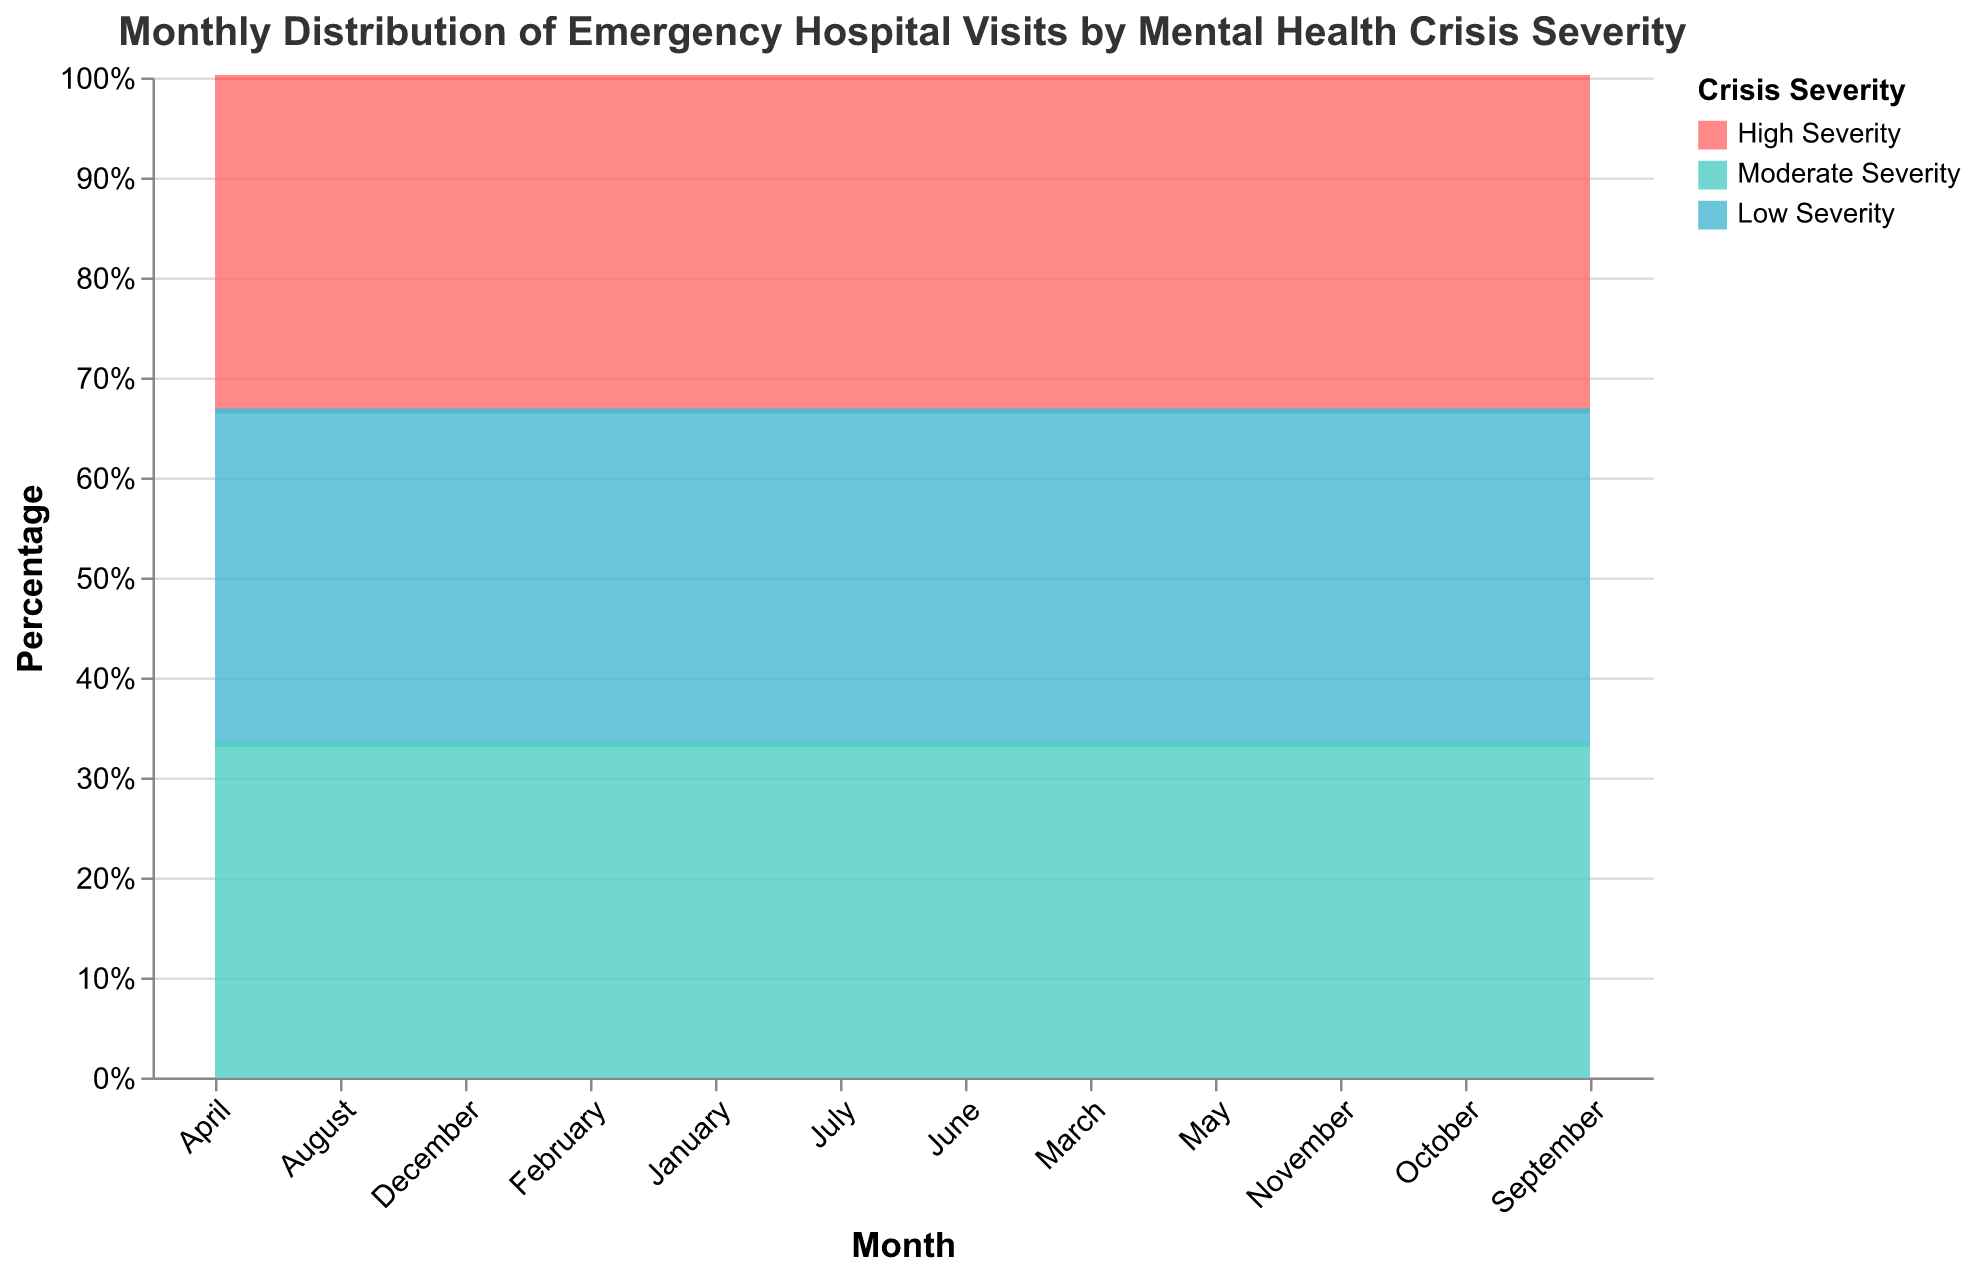What is the title of the chart? The title can be found at the top of the chart. It reads, "Monthly Distribution of Emergency Hospital Visits by Mental Health Crisis Severity."
Answer: Monthly Distribution of Emergency Hospital Visits by Mental Health Crisis Severity Which month has the highest percentage of high severity visits? By visually inspecting the chart, we can see that April and October have the highest normalized area for high severity, indicating these months have the highest proportion of high severity visits.
Answer: April and October How does the percentage of moderate severity visits in June compare with that in July? In June, the proportion of moderate severity visits is higher than in July, evident from the wider normalized area for June in the segment representing moderate severity.
Answer: Higher in June What is the trend for low severity visits from January to June? From January to June, the proportion of low severity visits sees a slight upward trend initially and then remains stable. This is visible by the fairly consistent area representing low severity across those months.
Answer: Slight upward trend then stable In which month do moderate severity visits surpass high severity visits? By examining the areas in each month, we can see that in June and August, the area representing moderate severity is larger than the area representing high severity, indicating moderate severity visits surpass high severity visits.
Answer: June and August What is the average percentage of high severity visits across all months? First, add up the percentage of high severity visits for all months: (40% + 35% + 45% + 50% + 40% + 30% + 30% + 35% + 45% + 50% + 40% + 45%) = 485%. Divide by 12 months to get the average: 485 / 12.
Answer: 40.42% Which month shows the smallest percentage of low severity visits? By looking at the 100% stacked area chart, the month with the smallest section of low severity is September, indicating this month has the lowest proportion of low severity visits.
Answer: September How do the percentages of crises severity in March compare to those in November? In March, the percentages are approximately high severity 45%, moderate severity 30%, and low severity 25%. In November, they are approximately high severity 40%, moderate severity 30%, and low severity 30%. By comparing these, we can see that high severity visits are higher in March, moderate severity remains consistent, and low severity is higher in November.
Answer: March: 45%, 30%, 25%; November: 40%, 30%, 30% What can you infer about the seasonal variation of high severity crises? High severity crises appear to have a peak in the spring (March, April) and fall (September, October), and are relatively lower in the summer and winter as visualized by the larger areas in those months.
Answer: Peaks in spring and fall, lower in summer and winter What is the overall trend of high and low severity visits over the year? The high severity visits show peaks during April and October, with fluctuations in other months. Low severity visits remain relatively stable but have a slight dip in the middle of the year around September.
Answer: Fluctuation with peaks for high severity, stable with a dip for low severity 